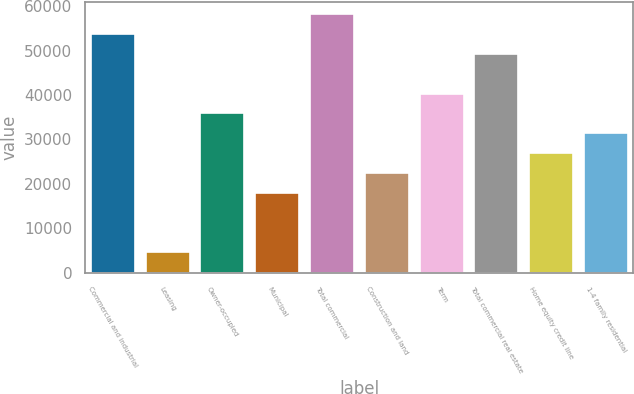<chart> <loc_0><loc_0><loc_500><loc_500><bar_chart><fcel>Commercial and industrial<fcel>Leasing<fcel>Owner-occupied<fcel>Municipal<fcel>Total commercial<fcel>Construction and land<fcel>Term<fcel>Total commercial real estate<fcel>Home equity credit line<fcel>1-4 family residential<nl><fcel>53699<fcel>4644.5<fcel>35861<fcel>18023<fcel>58158.5<fcel>22482.5<fcel>40320.5<fcel>49239.5<fcel>26942<fcel>31401.5<nl></chart> 